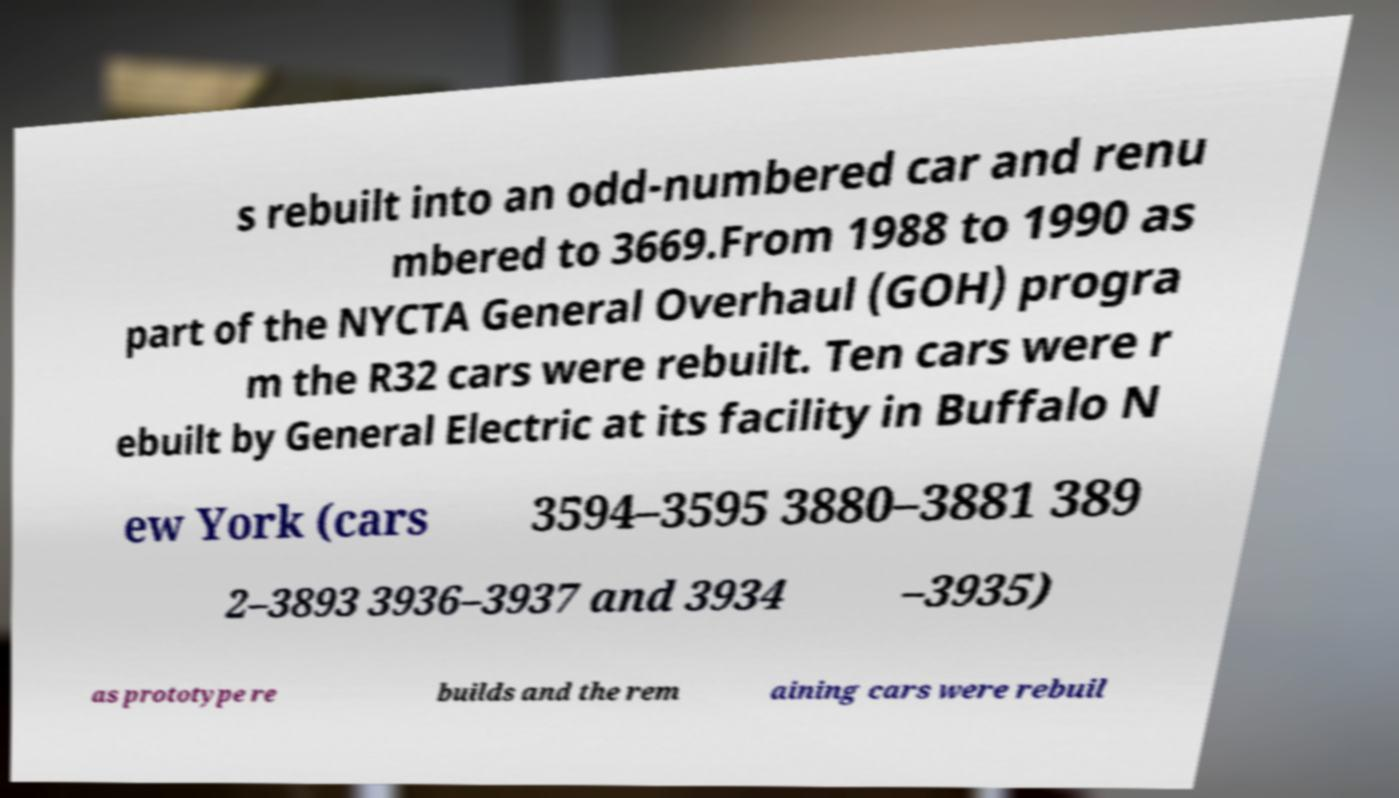Can you accurately transcribe the text from the provided image for me? s rebuilt into an odd-numbered car and renu mbered to 3669.From 1988 to 1990 as part of the NYCTA General Overhaul (GOH) progra m the R32 cars were rebuilt. Ten cars were r ebuilt by General Electric at its facility in Buffalo N ew York (cars 3594–3595 3880–3881 389 2–3893 3936–3937 and 3934 –3935) as prototype re builds and the rem aining cars were rebuil 